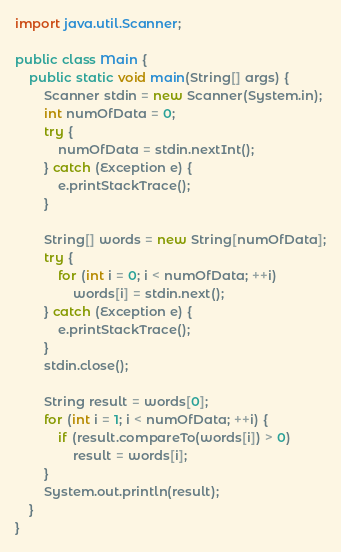Convert code to text. <code><loc_0><loc_0><loc_500><loc_500><_Java_>import java.util.Scanner;

public class Main {
	public static void main(String[] args) {
		Scanner stdin = new Scanner(System.in);
		int numOfData = 0;
		try {
			numOfData = stdin.nextInt();
		} catch (Exception e) {
			e.printStackTrace();
		}
		
		String[] words = new String[numOfData];
		try {
			for (int i = 0; i < numOfData; ++i)
				words[i] = stdin.next();
		} catch (Exception e) {
			e.printStackTrace();
		}
		stdin.close();
		
		String result = words[0];
		for (int i = 1; i < numOfData; ++i) {
			if (result.compareTo(words[i]) > 0)
				result = words[i];
		}
		System.out.println(result);
	}
}</code> 